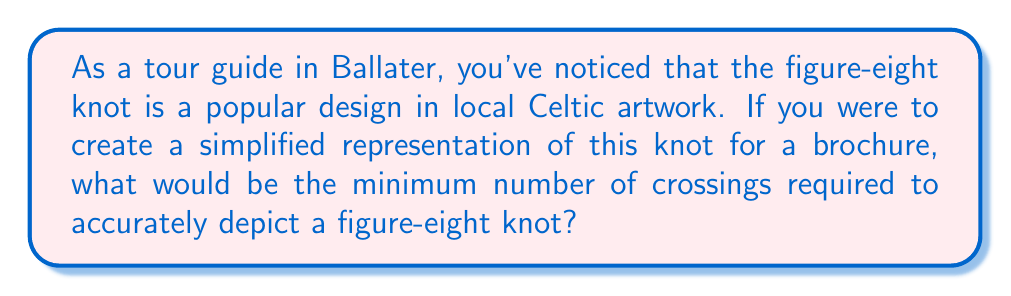Teach me how to tackle this problem. To determine the crossing number of a figure-eight knot, we need to follow these steps:

1. Understand the definition: The crossing number of a knot is the minimum number of crossings in any diagram of the knot.

2. Recognize the figure-eight knot: It's also known as the 4₁ knot in knot theory notation, which already hints at its crossing number.

3. Examine the standard diagram:
   The standard diagram of a figure-eight knot looks like this:
   
   [asy]
   import geometry;
   
   size(100);
   
   path p = (0,0)--(20,20)--(40,0)--(20,-20)--cycle;
   path q = (20,-20)--(40,0)--(60,-20)--(40,-40)--cycle;
   
   draw(p);
   draw(q);
   
   dot((20,20));
   dot((40,0));
   dot((20,-20));
   dot((60,-20));
   [/asy]

4. Count the crossings: In this standard representation, we can clearly see 4 crossings.

5. Prove minimality: It can be mathematically proven that it's impossible to represent a figure-eight knot with fewer than 4 crossings. This proof involves invariants such as the Jones polynomial, but it's beyond the scope of this explanation.

6. Conclude: The crossing number of the figure-eight knot is 4, and this is the minimum number of crossings needed to accurately depict it.
Answer: 4 